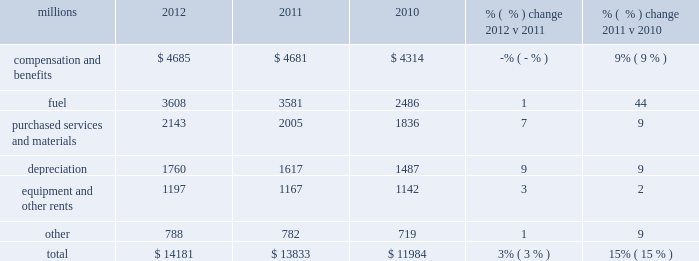Operating expenses millions 2012 2011 2010 % (  % ) change 2012 v 2011 % (  % ) change 2011 v 2010 .
Operating expenses increased $ 348 million in 2012 versus 2011 .
Depreciation , wage and benefit inflation , higher fuel prices and volume- related trucking services purchased by our logistics subsidiaries , contributed to higher expenses during the year .
Efficiency gains , volume related fuel savings ( 2% ( 2 % ) fewer gallons of fuel consumed ) and $ 38 million of weather related expenses in 2011 , which favorably affects the comparison , partially offset the cost increase .
Operating expenses increased $ 1.8 billion in 2011 versus 2010 .
Our fuel price per gallon rose 36% ( 36 % ) during 2011 , accounting for $ 922 million of the increase .
Wage and benefit inflation , volume-related costs , depreciation , and property taxes also contributed to higher expenses .
Expenses increased $ 20 million for costs related to the flooding in the midwest and $ 18 million due to the impact of severe heat and drought in the south , primarily texas .
Cost savings from productivity improvements and better resource utilization partially offset these increases .
A $ 45 million one-time payment relating to a transaction with csx intermodal , inc ( csxi ) increased operating expenses during the first quarter of 2010 , which favorably affects the comparison of operating expenses in 2011 to those in 2010 .
Compensation and benefits 2013 compensation and benefits include wages , payroll taxes , health and welfare costs , pension costs , other postretirement benefits , and incentive costs .
Expenses in 2012 were essentially flat versus 2011 as operational improvements and cost reductions offset general wage and benefit inflation and higher pension and other postretirement benefits .
In addition , weather related costs increased these expenses in 2011 .
A combination of general wage and benefit inflation , volume-related expenses , higher training costs associated with new hires , additional crew costs due to speed restrictions caused by the midwest flooding and heat and drought in the south , and higher pension expense drove the increase during 2011 compared to 2010 .
Fuel 2013 fuel includes locomotive fuel and gasoline for highway and non-highway vehicles and heavy equipment .
Higher locomotive diesel fuel prices , which averaged $ 3.22 per gallon ( including taxes and transportation costs ) in 2012 , compared to $ 3.12 in 2011 , increased expenses by $ 105 million .
Volume , as measured by gross ton-miles , decreased 2% ( 2 % ) in 2012 versus 2011 , driving expense down .
The fuel consumption rate was flat year-over-year .
Higher locomotive diesel fuel prices , which averaged $ 3.12 ( including taxes and transportation costs ) in 2011 , compared to $ 2.29 per gallon in 2010 , increased expenses by $ 922 million .
In addition , higher gasoline prices for highway and non-highway vehicles also increased year-over-year .
Volume , as measured by gross ton-miles , increased 5% ( 5 % ) in 2011 versus 2010 , driving expense up by $ 122 million .
Purchased services and materials 2013 expense for purchased services and materials includes the costs of services purchased from outside contractors and other service providers ( including equipment 2012 operating expenses .
The 2011 to 2012 change in equipment and other rents is what percent of the total expense increase in 2012? 
Computations: ((1197 - 1167) / (14181 - 13833))
Answer: 0.08621. Operating expenses millions 2012 2011 2010 % (  % ) change 2012 v 2011 % (  % ) change 2011 v 2010 .
Operating expenses increased $ 348 million in 2012 versus 2011 .
Depreciation , wage and benefit inflation , higher fuel prices and volume- related trucking services purchased by our logistics subsidiaries , contributed to higher expenses during the year .
Efficiency gains , volume related fuel savings ( 2% ( 2 % ) fewer gallons of fuel consumed ) and $ 38 million of weather related expenses in 2011 , which favorably affects the comparison , partially offset the cost increase .
Operating expenses increased $ 1.8 billion in 2011 versus 2010 .
Our fuel price per gallon rose 36% ( 36 % ) during 2011 , accounting for $ 922 million of the increase .
Wage and benefit inflation , volume-related costs , depreciation , and property taxes also contributed to higher expenses .
Expenses increased $ 20 million for costs related to the flooding in the midwest and $ 18 million due to the impact of severe heat and drought in the south , primarily texas .
Cost savings from productivity improvements and better resource utilization partially offset these increases .
A $ 45 million one-time payment relating to a transaction with csx intermodal , inc ( csxi ) increased operating expenses during the first quarter of 2010 , which favorably affects the comparison of operating expenses in 2011 to those in 2010 .
Compensation and benefits 2013 compensation and benefits include wages , payroll taxes , health and welfare costs , pension costs , other postretirement benefits , and incentive costs .
Expenses in 2012 were essentially flat versus 2011 as operational improvements and cost reductions offset general wage and benefit inflation and higher pension and other postretirement benefits .
In addition , weather related costs increased these expenses in 2011 .
A combination of general wage and benefit inflation , volume-related expenses , higher training costs associated with new hires , additional crew costs due to speed restrictions caused by the midwest flooding and heat and drought in the south , and higher pension expense drove the increase during 2011 compared to 2010 .
Fuel 2013 fuel includes locomotive fuel and gasoline for highway and non-highway vehicles and heavy equipment .
Higher locomotive diesel fuel prices , which averaged $ 3.22 per gallon ( including taxes and transportation costs ) in 2012 , compared to $ 3.12 in 2011 , increased expenses by $ 105 million .
Volume , as measured by gross ton-miles , decreased 2% ( 2 % ) in 2012 versus 2011 , driving expense down .
The fuel consumption rate was flat year-over-year .
Higher locomotive diesel fuel prices , which averaged $ 3.12 ( including taxes and transportation costs ) in 2011 , compared to $ 2.29 per gallon in 2010 , increased expenses by $ 922 million .
In addition , higher gasoline prices for highway and non-highway vehicles also increased year-over-year .
Volume , as measured by gross ton-miles , increased 5% ( 5 % ) in 2011 versus 2010 , driving expense up by $ 122 million .
Purchased services and materials 2013 expense for purchased services and materials includes the costs of services purchased from outside contractors and other service providers ( including equipment 2012 operating expenses .
Based on the calculated increase in locomotive diesel fuel price in 2012 , what is the estimated total fuel cost for 2012? 
Computations: ((105 / (3.22 - 3.12)) * 1000000)
Answer: 1050000000.0. Operating expenses millions 2012 2011 2010 % (  % ) change 2012 v 2011 % (  % ) change 2011 v 2010 .
Operating expenses increased $ 348 million in 2012 versus 2011 .
Depreciation , wage and benefit inflation , higher fuel prices and volume- related trucking services purchased by our logistics subsidiaries , contributed to higher expenses during the year .
Efficiency gains , volume related fuel savings ( 2% ( 2 % ) fewer gallons of fuel consumed ) and $ 38 million of weather related expenses in 2011 , which favorably affects the comparison , partially offset the cost increase .
Operating expenses increased $ 1.8 billion in 2011 versus 2010 .
Our fuel price per gallon rose 36% ( 36 % ) during 2011 , accounting for $ 922 million of the increase .
Wage and benefit inflation , volume-related costs , depreciation , and property taxes also contributed to higher expenses .
Expenses increased $ 20 million for costs related to the flooding in the midwest and $ 18 million due to the impact of severe heat and drought in the south , primarily texas .
Cost savings from productivity improvements and better resource utilization partially offset these increases .
A $ 45 million one-time payment relating to a transaction with csx intermodal , inc ( csxi ) increased operating expenses during the first quarter of 2010 , which favorably affects the comparison of operating expenses in 2011 to those in 2010 .
Compensation and benefits 2013 compensation and benefits include wages , payroll taxes , health and welfare costs , pension costs , other postretirement benefits , and incentive costs .
Expenses in 2012 were essentially flat versus 2011 as operational improvements and cost reductions offset general wage and benefit inflation and higher pension and other postretirement benefits .
In addition , weather related costs increased these expenses in 2011 .
A combination of general wage and benefit inflation , volume-related expenses , higher training costs associated with new hires , additional crew costs due to speed restrictions caused by the midwest flooding and heat and drought in the south , and higher pension expense drove the increase during 2011 compared to 2010 .
Fuel 2013 fuel includes locomotive fuel and gasoline for highway and non-highway vehicles and heavy equipment .
Higher locomotive diesel fuel prices , which averaged $ 3.22 per gallon ( including taxes and transportation costs ) in 2012 , compared to $ 3.12 in 2011 , increased expenses by $ 105 million .
Volume , as measured by gross ton-miles , decreased 2% ( 2 % ) in 2012 versus 2011 , driving expense down .
The fuel consumption rate was flat year-over-year .
Higher locomotive diesel fuel prices , which averaged $ 3.12 ( including taxes and transportation costs ) in 2011 , compared to $ 2.29 per gallon in 2010 , increased expenses by $ 922 million .
In addition , higher gasoline prices for highway and non-highway vehicles also increased year-over-year .
Volume , as measured by gross ton-miles , increased 5% ( 5 % ) in 2011 versus 2010 , driving expense up by $ 122 million .
Purchased services and materials 2013 expense for purchased services and materials includes the costs of services purchased from outside contractors and other service providers ( including equipment 2012 operating expenses .
What percentage of total operating expenses was purchased services and materials in 2012? 
Computations: (2143 / 14181)
Answer: 0.15112. 